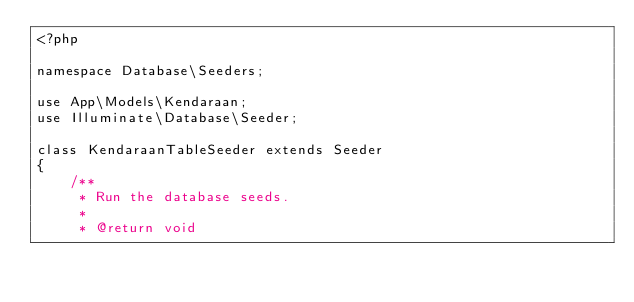Convert code to text. <code><loc_0><loc_0><loc_500><loc_500><_PHP_><?php

namespace Database\Seeders;

use App\Models\Kendaraan;
use Illuminate\Database\Seeder;

class KendaraanTableSeeder extends Seeder
{
    /**
     * Run the database seeds.
     *
     * @return void</code> 